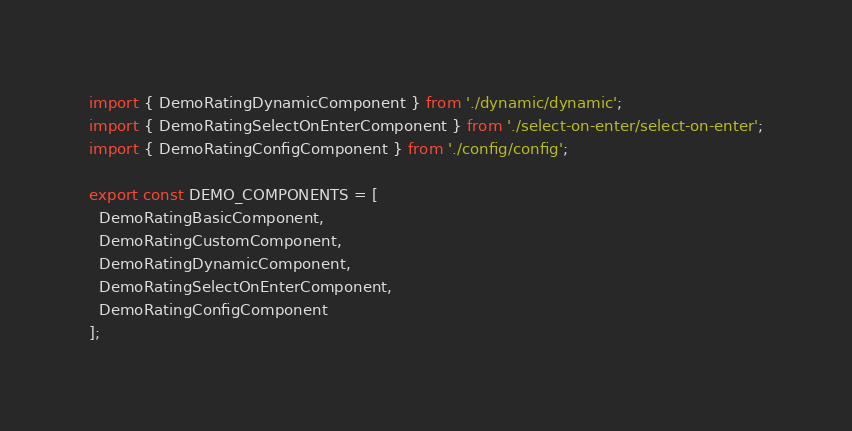Convert code to text. <code><loc_0><loc_0><loc_500><loc_500><_TypeScript_>import { DemoRatingDynamicComponent } from './dynamic/dynamic';
import { DemoRatingSelectOnEnterComponent } from './select-on-enter/select-on-enter';
import { DemoRatingConfigComponent } from './config/config';

export const DEMO_COMPONENTS = [
  DemoRatingBasicComponent,
  DemoRatingCustomComponent,
  DemoRatingDynamicComponent,
  DemoRatingSelectOnEnterComponent,
  DemoRatingConfigComponent
];
</code> 